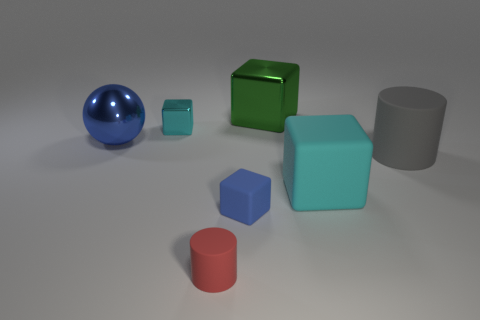There is a small block that is the same color as the large ball; what is it made of?
Keep it short and to the point. Rubber. The red object that is the same material as the big gray object is what shape?
Offer a very short reply. Cylinder. Is the number of rubber cubes that are behind the blue matte cube greater than the number of large cyan things that are to the left of the red thing?
Ensure brevity in your answer.  Yes. What number of things are either blue metal spheres or green cubes?
Your answer should be compact. 2. How many other objects are the same color as the sphere?
Make the answer very short. 1. What shape is the gray thing that is the same size as the cyan rubber thing?
Offer a terse response. Cylinder. What is the color of the matte block left of the big shiny block?
Offer a very short reply. Blue. What number of things are either blocks to the left of the small blue matte object or blue things that are to the right of the small red thing?
Give a very brief answer. 2. Does the blue cube have the same size as the red thing?
Give a very brief answer. Yes. What number of blocks are large blue things or rubber objects?
Make the answer very short. 2. 